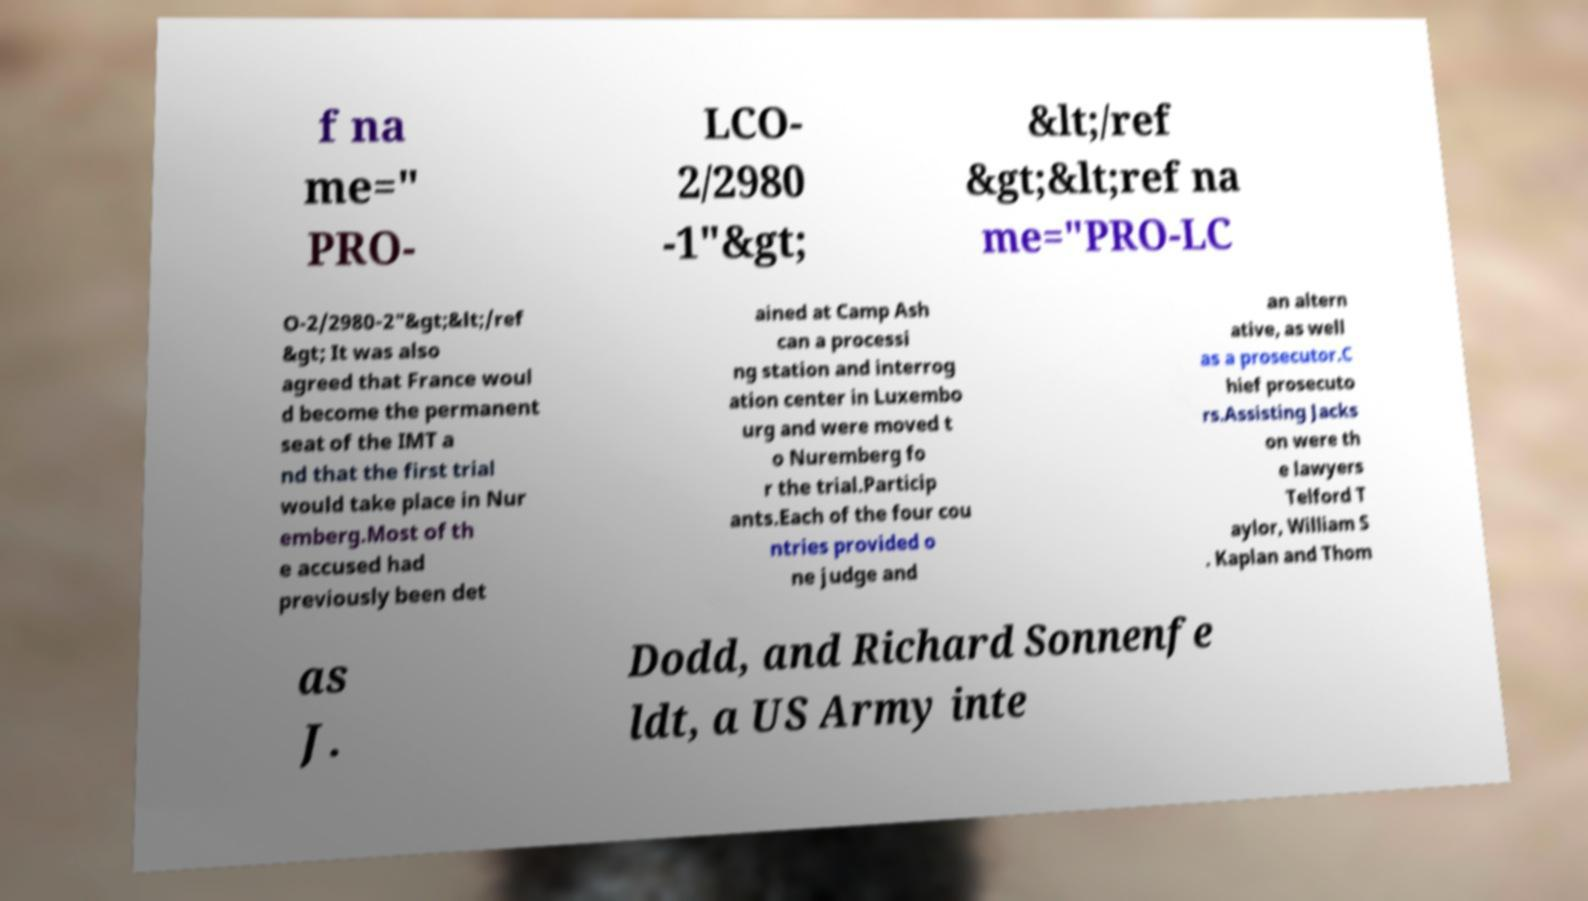Can you read and provide the text displayed in the image?This photo seems to have some interesting text. Can you extract and type it out for me? f na me=" PRO- LCO- 2/2980 -1"&gt; &lt;/ref &gt;&lt;ref na me="PRO-LC O-2/2980-2"&gt;&lt;/ref &gt; It was also agreed that France woul d become the permanent seat of the IMT a nd that the first trial would take place in Nur emberg.Most of th e accused had previously been det ained at Camp Ash can a processi ng station and interrog ation center in Luxembo urg and were moved t o Nuremberg fo r the trial.Particip ants.Each of the four cou ntries provided o ne judge and an altern ative, as well as a prosecutor.C hief prosecuto rs.Assisting Jacks on were th e lawyers Telford T aylor, William S . Kaplan and Thom as J. Dodd, and Richard Sonnenfe ldt, a US Army inte 